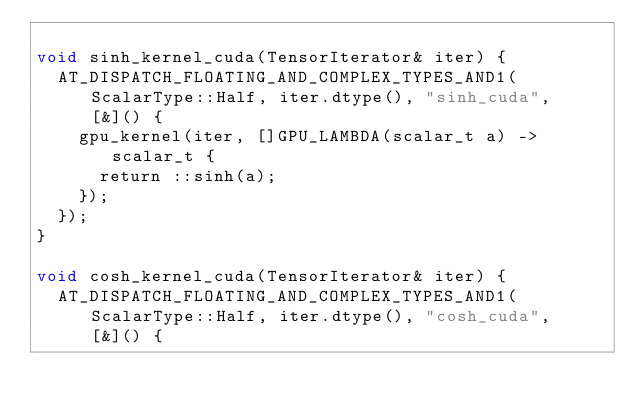<code> <loc_0><loc_0><loc_500><loc_500><_Cuda_>
void sinh_kernel_cuda(TensorIterator& iter) {
  AT_DISPATCH_FLOATING_AND_COMPLEX_TYPES_AND1(ScalarType::Half, iter.dtype(), "sinh_cuda", [&]() {
    gpu_kernel(iter, []GPU_LAMBDA(scalar_t a) -> scalar_t {
      return ::sinh(a);
    });
  });
}

void cosh_kernel_cuda(TensorIterator& iter) {
  AT_DISPATCH_FLOATING_AND_COMPLEX_TYPES_AND1(ScalarType::Half, iter.dtype(), "cosh_cuda", [&]() {</code> 